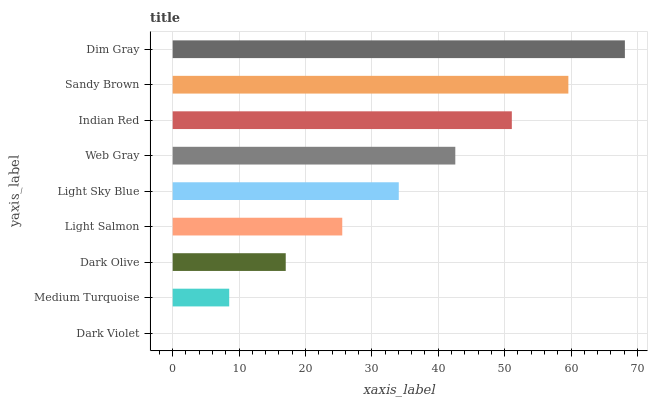Is Dark Violet the minimum?
Answer yes or no. Yes. Is Dim Gray the maximum?
Answer yes or no. Yes. Is Medium Turquoise the minimum?
Answer yes or no. No. Is Medium Turquoise the maximum?
Answer yes or no. No. Is Medium Turquoise greater than Dark Violet?
Answer yes or no. Yes. Is Dark Violet less than Medium Turquoise?
Answer yes or no. Yes. Is Dark Violet greater than Medium Turquoise?
Answer yes or no. No. Is Medium Turquoise less than Dark Violet?
Answer yes or no. No. Is Light Sky Blue the high median?
Answer yes or no. Yes. Is Light Sky Blue the low median?
Answer yes or no. Yes. Is Dim Gray the high median?
Answer yes or no. No. Is Dim Gray the low median?
Answer yes or no. No. 